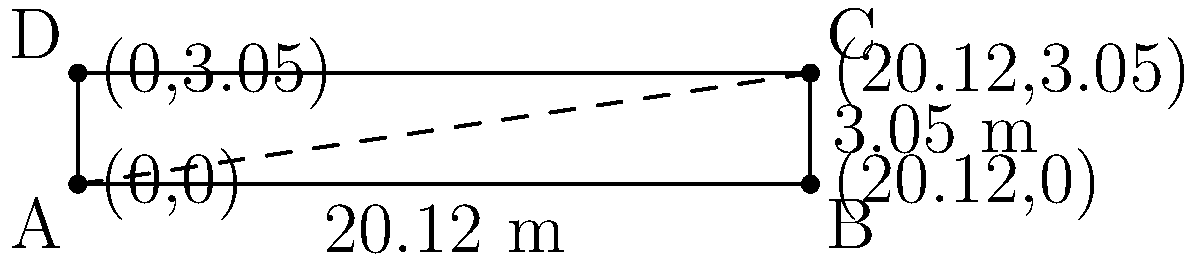In a thrilling match between Chennai Super Kings and Mumbai Indians, the umpire needs to quickly measure the diagonal length of the pitch. Given that a cricket pitch is 20.12 meters long and 3.05 meters wide, what is the length of the diagonal to the nearest centimeter? (Hint: This might help CSK's captain Dhoni strategize his field placements better against MI!) Let's solve this step-by-step:

1) The pitch forms a rectangle. To find the diagonal, we can use the Pythagorean theorem.

2) Let's denote:
   Length of the pitch = $a = 20.12$ m
   Width of the pitch = $b = 3.05$ m
   Diagonal of the pitch = $c$

3) According to the Pythagorean theorem:
   $c^2 = a^2 + b^2$

4) Substituting the values:
   $c^2 = 20.12^2 + 3.05^2$

5) Calculate:
   $c^2 = 404.8144 + 9.3025 = 414.1169$

6) Take the square root of both sides:
   $c = \sqrt{414.1169} = 20.3498...$ m

7) Rounding to the nearest centimeter:
   $c \approx 20.35$ m

Therefore, the diagonal length of the pitch is approximately 20.35 meters.
Answer: 20.35 m 